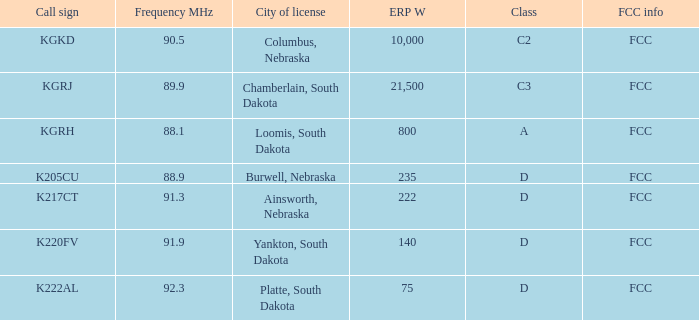What is the peak erp w when the frequency is 9 10000.0. 